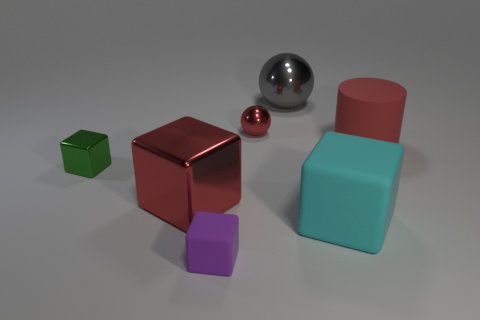Subtract all small matte cubes. How many cubes are left? 3 Subtract all purple cubes. How many cubes are left? 3 Subtract 3 blocks. How many blocks are left? 1 Add 2 big cylinders. How many objects exist? 9 Subtract all cubes. How many objects are left? 3 Add 4 small red metal objects. How many small red metal objects exist? 5 Subtract 0 purple balls. How many objects are left? 7 Subtract all blue blocks. Subtract all yellow spheres. How many blocks are left? 4 Subtract all green cylinders. Subtract all small green objects. How many objects are left? 6 Add 7 cyan blocks. How many cyan blocks are left? 8 